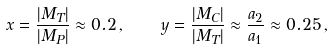Convert formula to latex. <formula><loc_0><loc_0><loc_500><loc_500>x = \frac { | M _ { T } | } { | M _ { P } | } \approx 0 . 2 \, , \quad y = \frac { | M _ { C } | } { | M _ { T } | } \approx \frac { a _ { 2 } } { a _ { 1 } } \approx 0 . 2 5 \, ,</formula> 